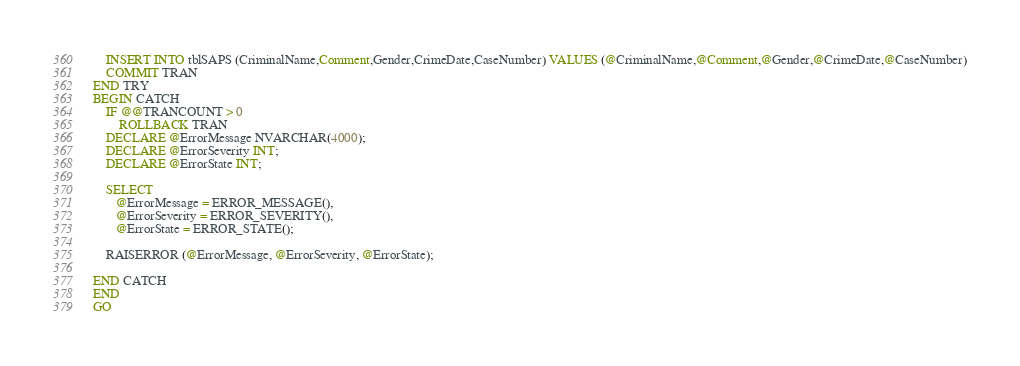Convert code to text. <code><loc_0><loc_0><loc_500><loc_500><_SQL_>	INSERT INTO tblSAPS (CriminalName,Comment,Gender,CrimeDate,CaseNumber) VALUES (@CriminalName,@Comment,@Gender,@CrimeDate,@CaseNumber)
    COMMIT TRAN 
END TRY
BEGIN CATCH
    IF @@TRANCOUNT > 0
        ROLLBACK TRAN 
    DECLARE @ErrorMessage NVARCHAR(4000);  
    DECLARE @ErrorSeverity INT;  
    DECLARE @ErrorState INT;  

    SELECT   
       @ErrorMessage = ERROR_MESSAGE(),  
       @ErrorSeverity = ERROR_SEVERITY(),  
       @ErrorState = ERROR_STATE();  

    RAISERROR (@ErrorMessage, @ErrorSeverity, @ErrorState);  
    
END CATCH
END
GO


</code> 